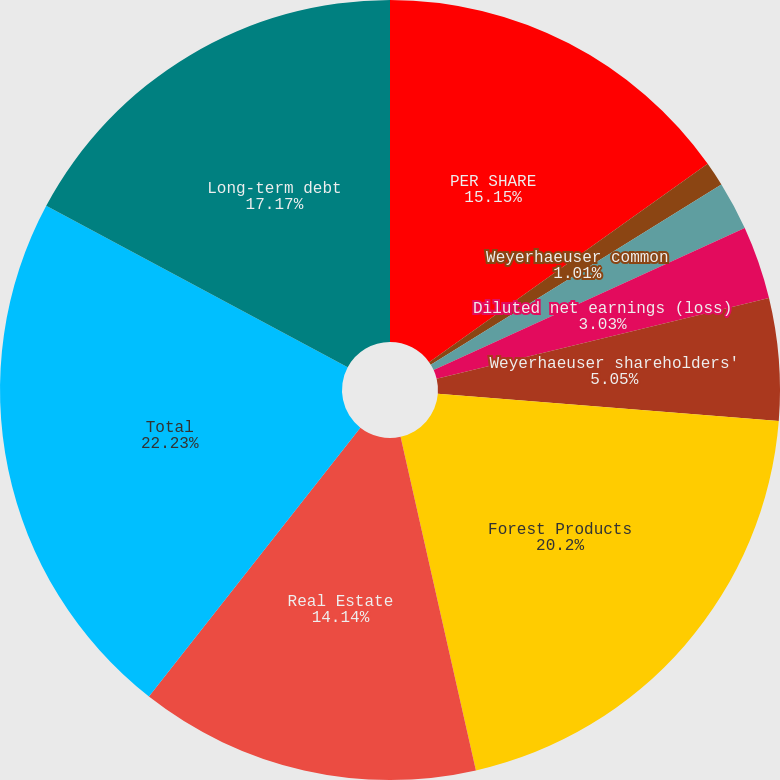<chart> <loc_0><loc_0><loc_500><loc_500><pie_chart><fcel>PER SHARE<fcel>Weyerhaeuser common<fcel>Basic net earnings (loss)<fcel>Diluted net earnings (loss)<fcel>Dividends paid<fcel>Weyerhaeuser shareholders'<fcel>Forest Products<fcel>Real Estate<fcel>Total<fcel>Long-term debt<nl><fcel>15.15%<fcel>1.01%<fcel>2.02%<fcel>3.03%<fcel>0.0%<fcel>5.05%<fcel>20.2%<fcel>14.14%<fcel>22.22%<fcel>17.17%<nl></chart> 